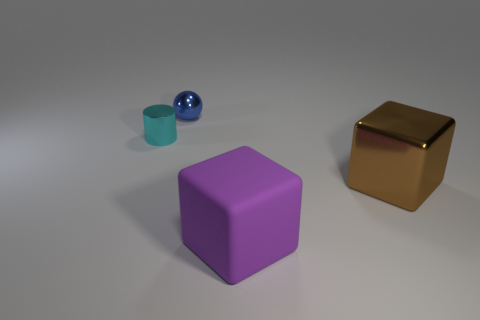Add 1 large yellow matte cylinders. How many objects exist? 5 Subtract all spheres. How many objects are left? 3 Add 1 cyan shiny objects. How many cyan shiny objects are left? 2 Add 4 large brown cubes. How many large brown cubes exist? 5 Subtract 0 blue blocks. How many objects are left? 4 Subtract all yellow rubber cylinders. Subtract all big brown things. How many objects are left? 3 